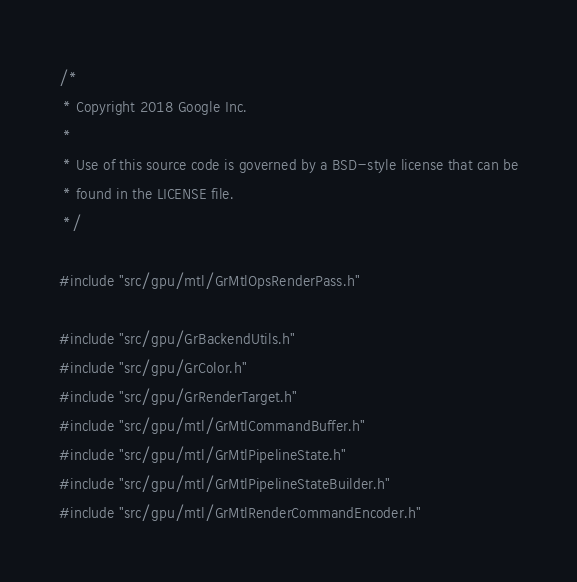Convert code to text. <code><loc_0><loc_0><loc_500><loc_500><_ObjectiveC_>/*
 * Copyright 2018 Google Inc.
 *
 * Use of this source code is governed by a BSD-style license that can be
 * found in the LICENSE file.
 */

#include "src/gpu/mtl/GrMtlOpsRenderPass.h"

#include "src/gpu/GrBackendUtils.h"
#include "src/gpu/GrColor.h"
#include "src/gpu/GrRenderTarget.h"
#include "src/gpu/mtl/GrMtlCommandBuffer.h"
#include "src/gpu/mtl/GrMtlPipelineState.h"
#include "src/gpu/mtl/GrMtlPipelineStateBuilder.h"
#include "src/gpu/mtl/GrMtlRenderCommandEncoder.h"</code> 